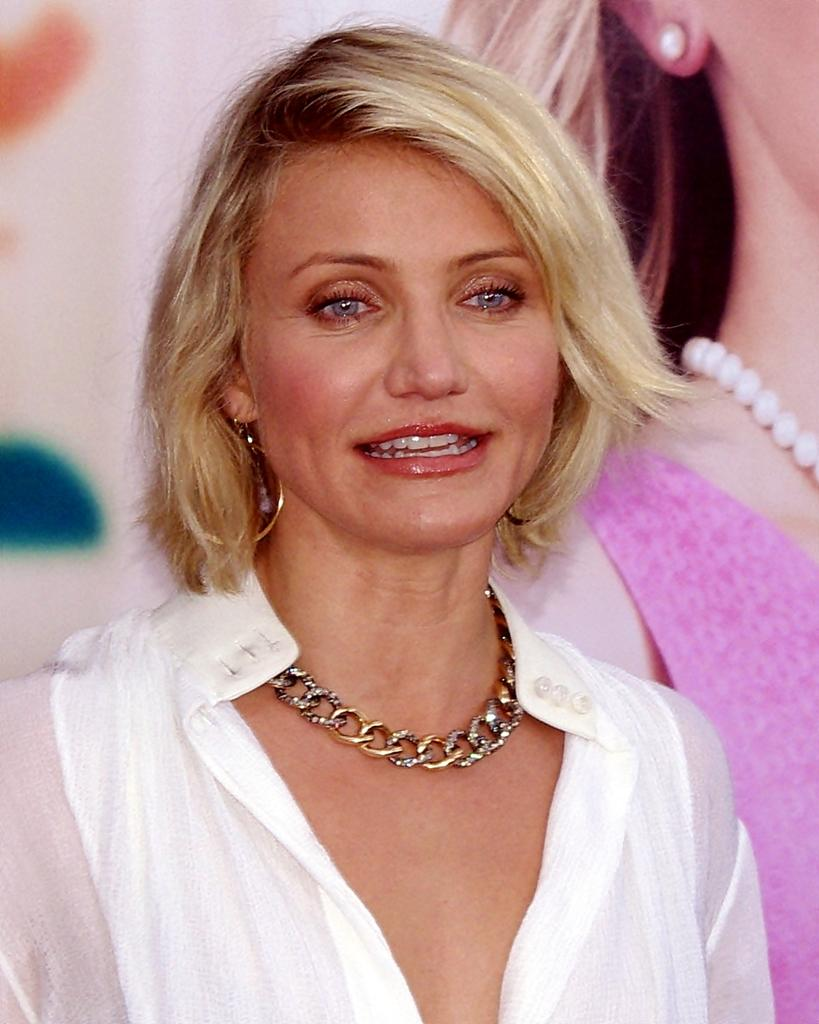How many people are present in the image? There are two women in the image. What can be seen in the background of the image? The background of the image is white. What type of punishment is the woman on the left receiving in the image? There is no indication of punishment in the image; it simply shows two women. 